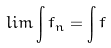Convert formula to latex. <formula><loc_0><loc_0><loc_500><loc_500>l i m \int f _ { n } = \int f</formula> 